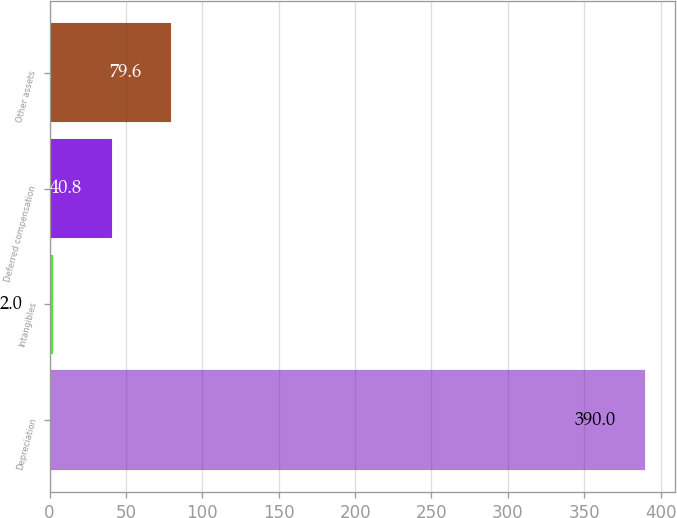Convert chart. <chart><loc_0><loc_0><loc_500><loc_500><bar_chart><fcel>Depreciation<fcel>Intangibles<fcel>Deferred compensation<fcel>Other assets<nl><fcel>390<fcel>2<fcel>40.8<fcel>79.6<nl></chart> 